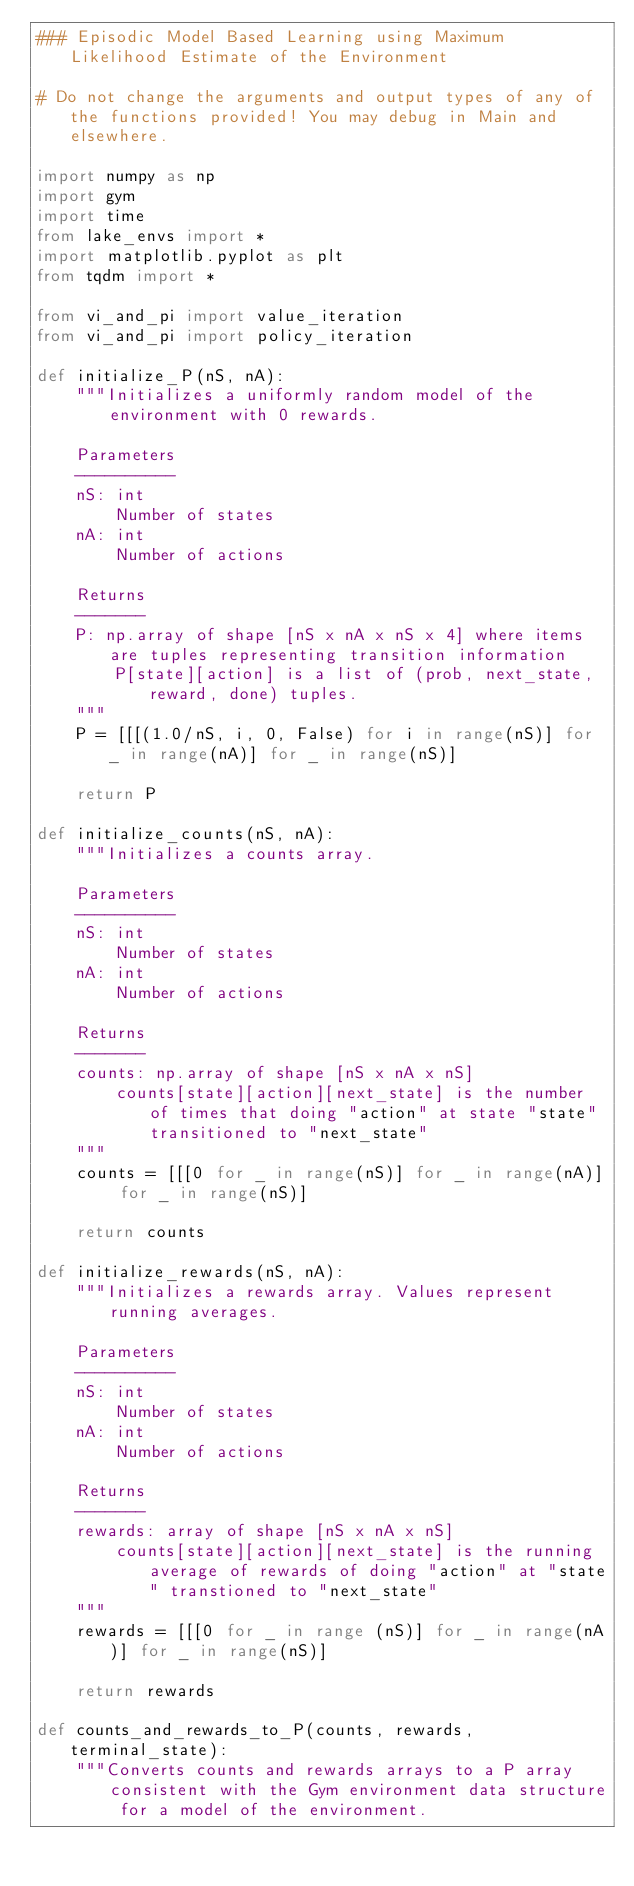<code> <loc_0><loc_0><loc_500><loc_500><_Python_>### Episodic Model Based Learning using Maximum Likelihood Estimate of the Environment

# Do not change the arguments and output types of any of the functions provided! You may debug in Main and elsewhere.

import numpy as np
import gym
import time
from lake_envs import *
import matplotlib.pyplot as plt
from tqdm import *

from vi_and_pi import value_iteration
from vi_and_pi import policy_iteration

def initialize_P(nS, nA):
    """Initializes a uniformly random model of the environment with 0 rewards.

    Parameters
    ----------
    nS: int
        Number of states
    nA: int
        Number of actions

    Returns
    -------
    P: np.array of shape [nS x nA x nS x 4] where items are tuples representing transition information
        P[state][action] is a list of (prob, next_state, reward, done) tuples.
    """
    P = [[[(1.0/nS, i, 0, False) for i in range(nS)] for _ in range(nA)] for _ in range(nS)]

    return P

def initialize_counts(nS, nA):
    """Initializes a counts array.

    Parameters
    ----------
    nS: int
        Number of states
    nA: int
        Number of actions

    Returns
    -------
    counts: np.array of shape [nS x nA x nS]
        counts[state][action][next_state] is the number of times that doing "action" at state "state" transitioned to "next_state"
    """
    counts = [[[0 for _ in range(nS)] for _ in range(nA)] for _ in range(nS)]

    return counts

def initialize_rewards(nS, nA):
    """Initializes a rewards array. Values represent running averages.

    Parameters
    ----------
    nS: int
        Number of states
    nA: int
        Number of actions

    Returns
    -------
    rewards: array of shape [nS x nA x nS]
        counts[state][action][next_state] is the running average of rewards of doing "action" at "state" transtioned to "next_state"
    """
    rewards = [[[0 for _ in range (nS)] for _ in range(nA)] for _ in range(nS)]

    return rewards

def counts_and_rewards_to_P(counts, rewards, terminal_state):
    """Converts counts and rewards arrays to a P array consistent with the Gym environment data structure for a model of the environment.</code> 